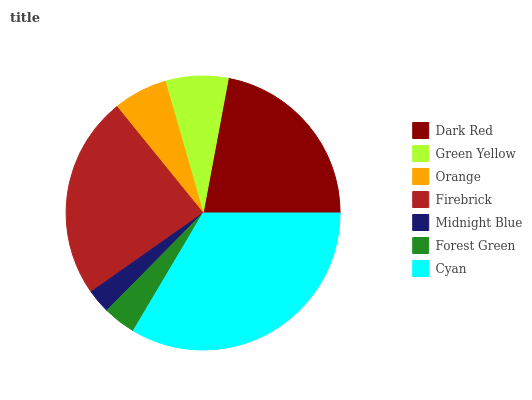Is Midnight Blue the minimum?
Answer yes or no. Yes. Is Cyan the maximum?
Answer yes or no. Yes. Is Green Yellow the minimum?
Answer yes or no. No. Is Green Yellow the maximum?
Answer yes or no. No. Is Dark Red greater than Green Yellow?
Answer yes or no. Yes. Is Green Yellow less than Dark Red?
Answer yes or no. Yes. Is Green Yellow greater than Dark Red?
Answer yes or no. No. Is Dark Red less than Green Yellow?
Answer yes or no. No. Is Green Yellow the high median?
Answer yes or no. Yes. Is Green Yellow the low median?
Answer yes or no. Yes. Is Forest Green the high median?
Answer yes or no. No. Is Dark Red the low median?
Answer yes or no. No. 